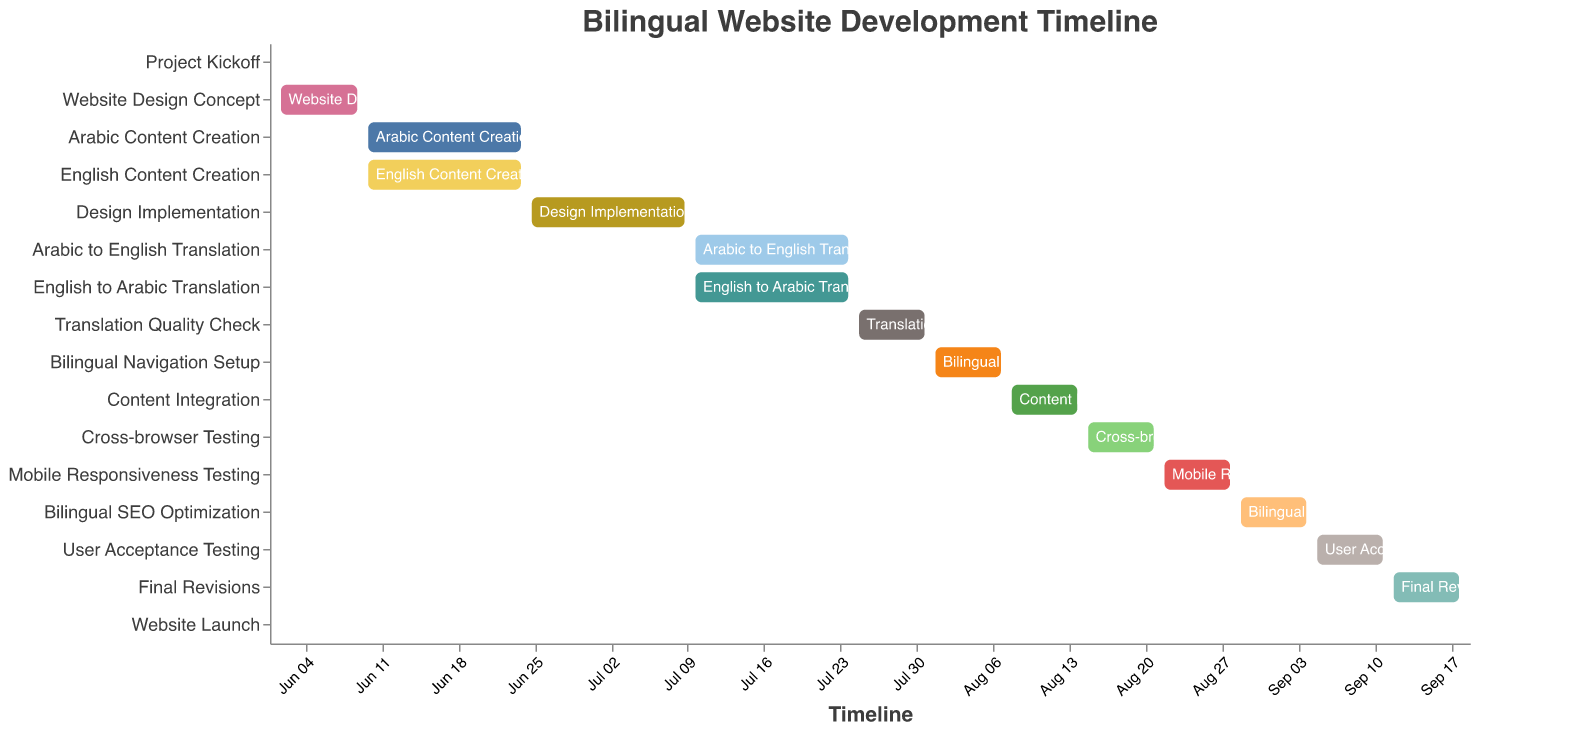What's the total duration of the project from start to launch? To calculate the total duration, find the difference between the start date of the first task (Project Kickoff, 2023-06-01) and the end date of the last task (Website Launch, 2023-09-19). This is 110 days.
Answer: 110 days How many tasks are completed by the end of June? By the end of June, the tasks completed are: Project Kickoff, Website Design Concept, Arabic Content Creation, English Content Creation, and Design Implementation.
Answer: 5 Which task has the longest duration? Identify the task with the highest duration value. Both "Arabic Content Creation" and "English Content Creation" have the longest duration of 15 days each.
Answer: Arabic Content Creation & English Content Creation When does the "Translation Quality Check" start and end? Reference the "Translation Quality Check" row in the figure which indicates the start and end dates. It starts on 2023-07-25 and ends on 2023-07-31.
Answer: Starts: 2023-07-25, Ends: 2023-07-31 What's the sequence of tasks in July? Starting from July 1st, the tasks are: Design Implementation completion, Arabic to English Translation, English to Arabic Translation, and Translation Quality Check.
Answer: Design Implementation, Arabic to English Translation, English to Arabic Translation, Translation Quality Check How many tasks overlap with the "Arabic to English Translation" phase? Cross-reference the "Arabic to English Translation" dates (2023-07-10 to 2023-07-24) with other tasks to determine overlaps. The overlapping tasks are "English to Arabic Translation."
Answer: 1 Which tasks are scheduled to start immediately after the "Translation Quality Check"? Identify the tasks that begin after the "Translation Quality Check" end date of 2023-07-31. These are Bilingual Navigation Setup and Content Integration.
Answer: Bilingual Navigation Setup What is the duration of the "Bilingual SEO Optimization" task? Look at the "Bilingual SEO Optimization" and find the difference between its start (2023-08-29) and end date (2023-09-04). The difference is 7 days.
Answer: 7 days What tasks are performed in parallel with "User Acceptance Testing"? Compare the "User Acceptance Testing" dates (2023-09-05 to 2023-09-11) to find any overlapping tasks. There are no overlapping tasks.
Answer: None How much time is allocated for testing phases overall? Sum the durations of all testing tasks: "Cross-browser Testing", "Mobile Responsiveness Testing", "User Acceptance Testing". Each has 7 days. Thus, 7 + 7 + 7 = 21 days.
Answer: 21 days 